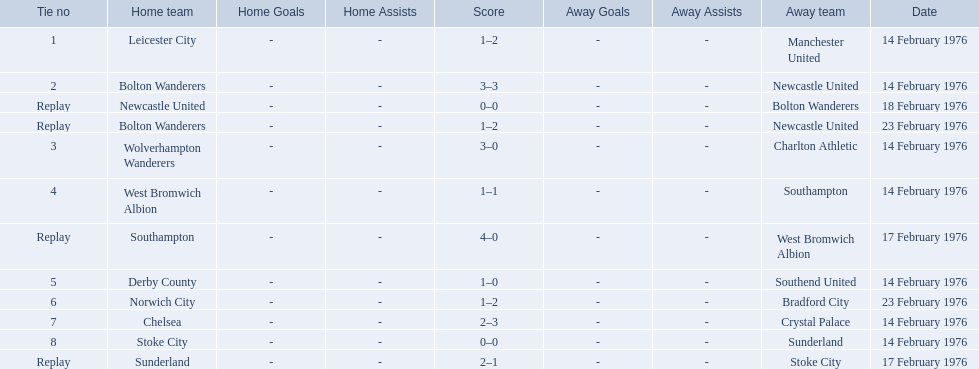What teams are featured in the game at the top of the table? Leicester City, Manchester United. Which of these two is the home team? Leicester City. What were the home teams in the 1975-76 fa cup? Leicester City, Bolton Wanderers, Newcastle United, Bolton Wanderers, Wolverhampton Wanderers, West Bromwich Albion, Southampton, Derby County, Norwich City, Chelsea, Stoke City, Sunderland. Which of these teams had the tie number 1? Leicester City. 